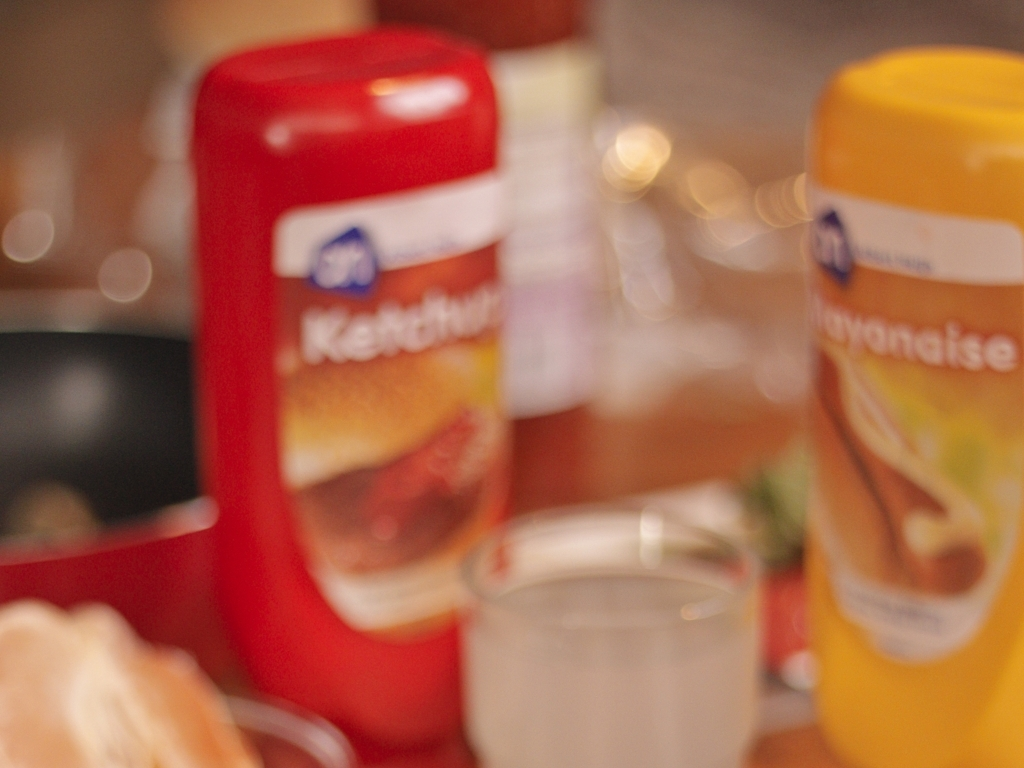Are there any noise artifacts present in the image? Based on the assessment of the image, it appears to be free from what would typically be classified as noise artifacts, though it does exhibit significant blurring which affects the sharpness and detail of the objects within. 